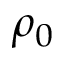Convert formula to latex. <formula><loc_0><loc_0><loc_500><loc_500>\rho _ { 0 }</formula> 